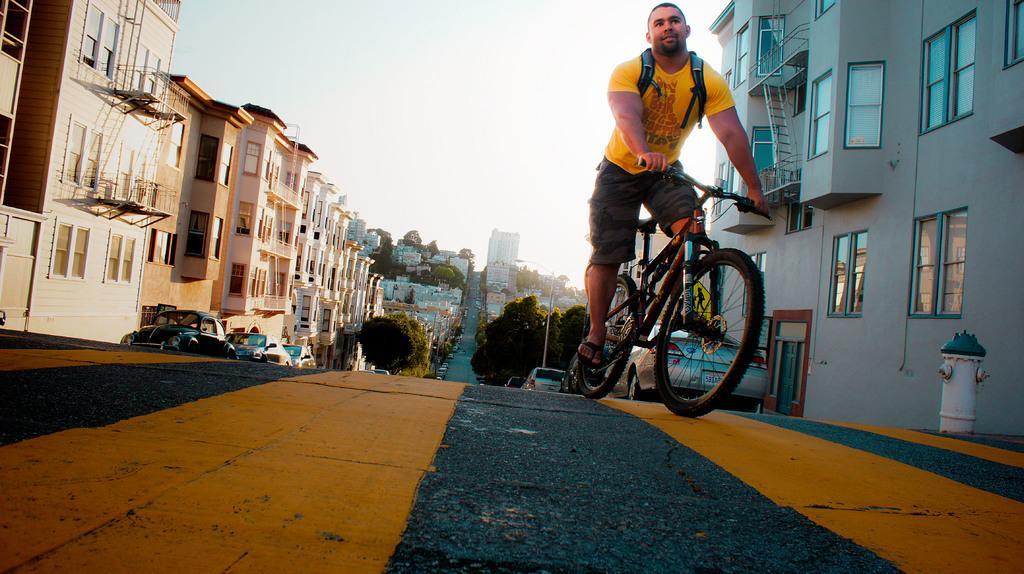Please provide a concise description of this image. I think this picture is inside the city. There is a person riding bicycle on the road and at the left side of the image there are many vehicles on the road and at the both left and right side of the image there are buildings, trees. At the top there is a sky. 